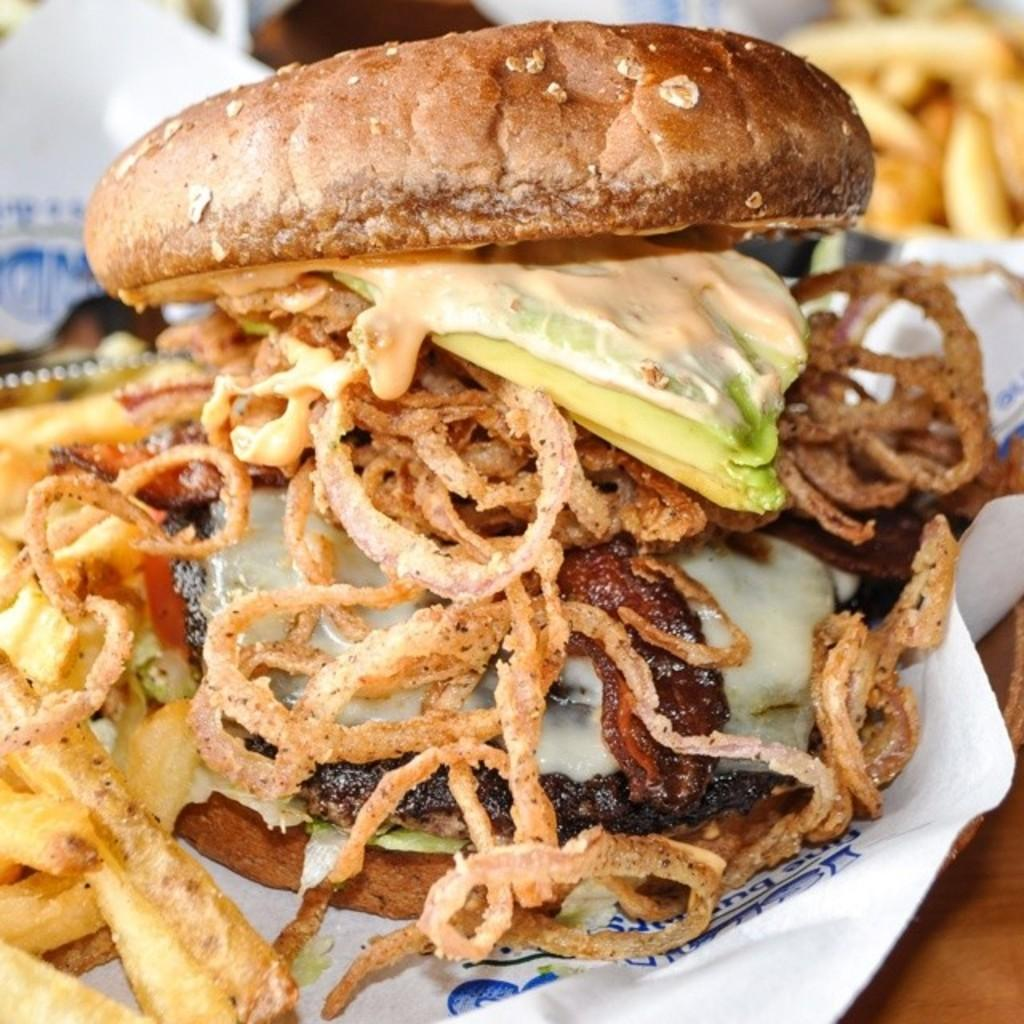What can be found on the table in the image? There are food items on the table. What else is present on the table besides the food items? Tissue paper is present on the table. What type of wool is being used to create the angle of the table in the image? There is no wool or angle mentioned in the image; it only shows food items and tissue paper on a table. 